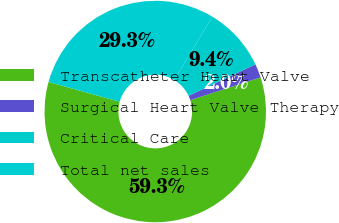Convert chart. <chart><loc_0><loc_0><loc_500><loc_500><pie_chart><fcel>Transcatheter Heart Valve<fcel>Surgical Heart Valve Therapy<fcel>Critical Care<fcel>Total net sales<nl><fcel>59.28%<fcel>2.03%<fcel>9.36%<fcel>29.33%<nl></chart> 